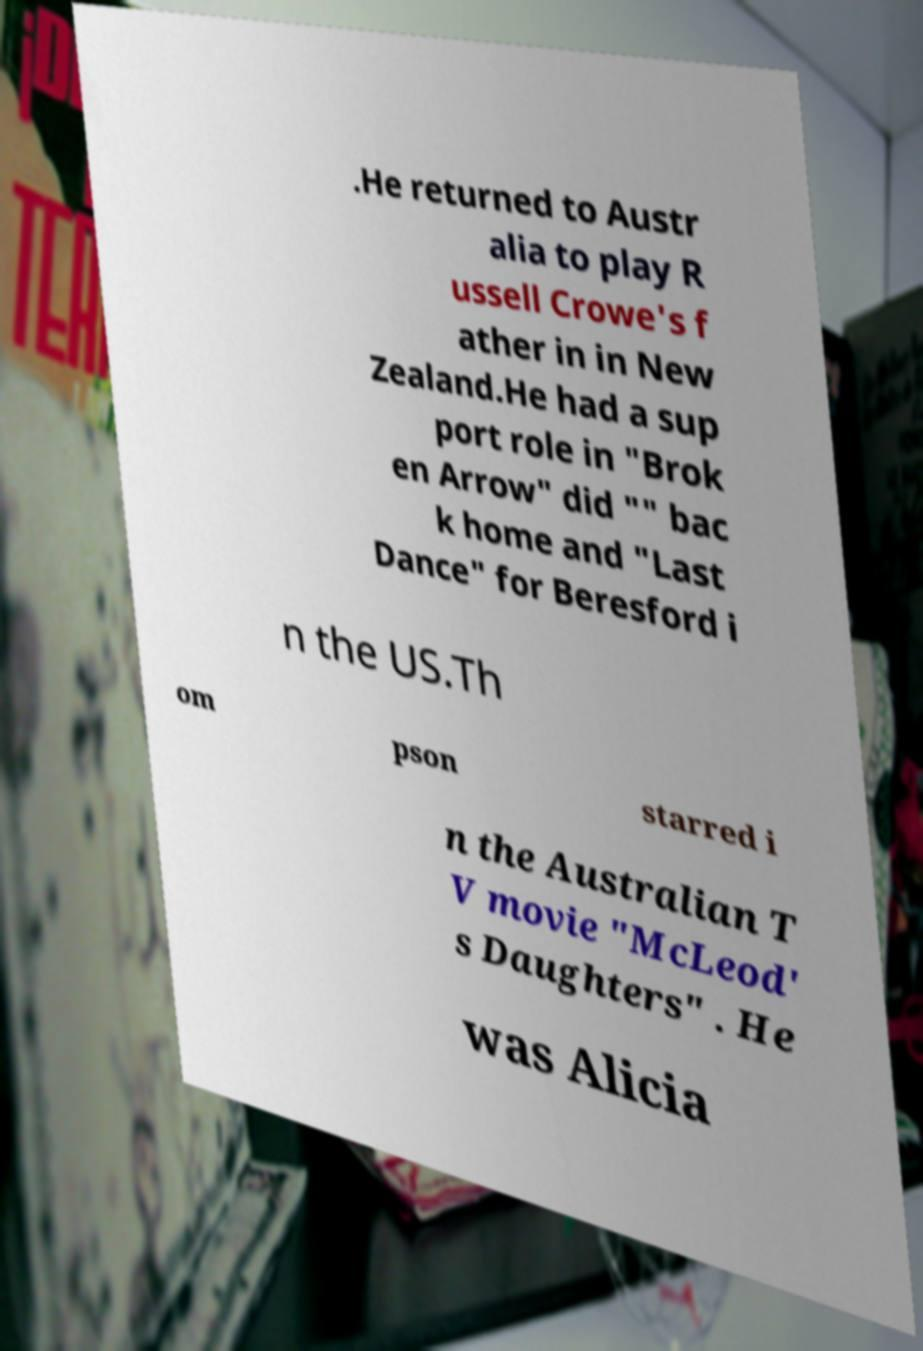For documentation purposes, I need the text within this image transcribed. Could you provide that? .He returned to Austr alia to play R ussell Crowe's f ather in in New Zealand.He had a sup port role in "Brok en Arrow" did "" bac k home and "Last Dance" for Beresford i n the US.Th om pson starred i n the Australian T V movie "McLeod' s Daughters" . He was Alicia 